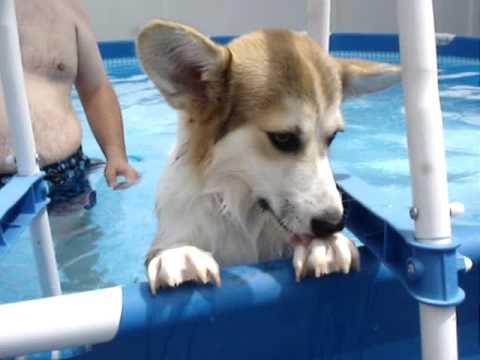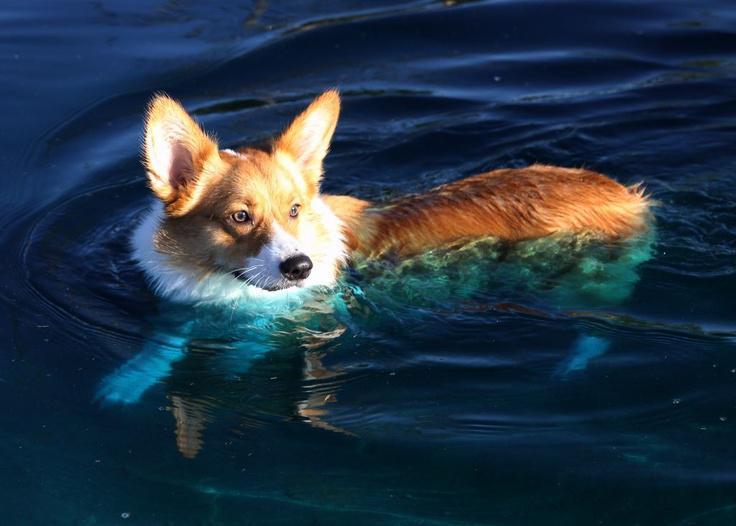The first image is the image on the left, the second image is the image on the right. For the images shown, is this caption "there is at least one corgi in a pool on an inflatable mat wearing sunglasses with it's tongue sticking out" true? Answer yes or no. No. 